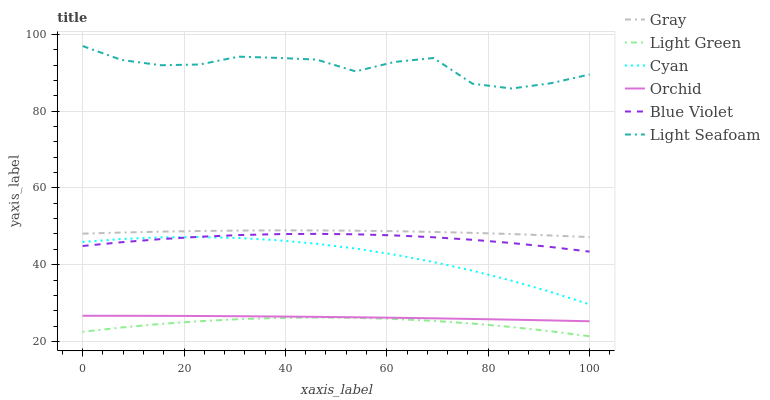Does Light Green have the minimum area under the curve?
Answer yes or no. Yes. Does Light Seafoam have the maximum area under the curve?
Answer yes or no. Yes. Does Cyan have the minimum area under the curve?
Answer yes or no. No. Does Cyan have the maximum area under the curve?
Answer yes or no. No. Is Orchid the smoothest?
Answer yes or no. Yes. Is Light Seafoam the roughest?
Answer yes or no. Yes. Is Light Green the smoothest?
Answer yes or no. No. Is Light Green the roughest?
Answer yes or no. No. Does Light Green have the lowest value?
Answer yes or no. Yes. Does Cyan have the lowest value?
Answer yes or no. No. Does Light Seafoam have the highest value?
Answer yes or no. Yes. Does Cyan have the highest value?
Answer yes or no. No. Is Gray less than Light Seafoam?
Answer yes or no. Yes. Is Light Seafoam greater than Light Green?
Answer yes or no. Yes. Does Blue Violet intersect Cyan?
Answer yes or no. Yes. Is Blue Violet less than Cyan?
Answer yes or no. No. Is Blue Violet greater than Cyan?
Answer yes or no. No. Does Gray intersect Light Seafoam?
Answer yes or no. No. 